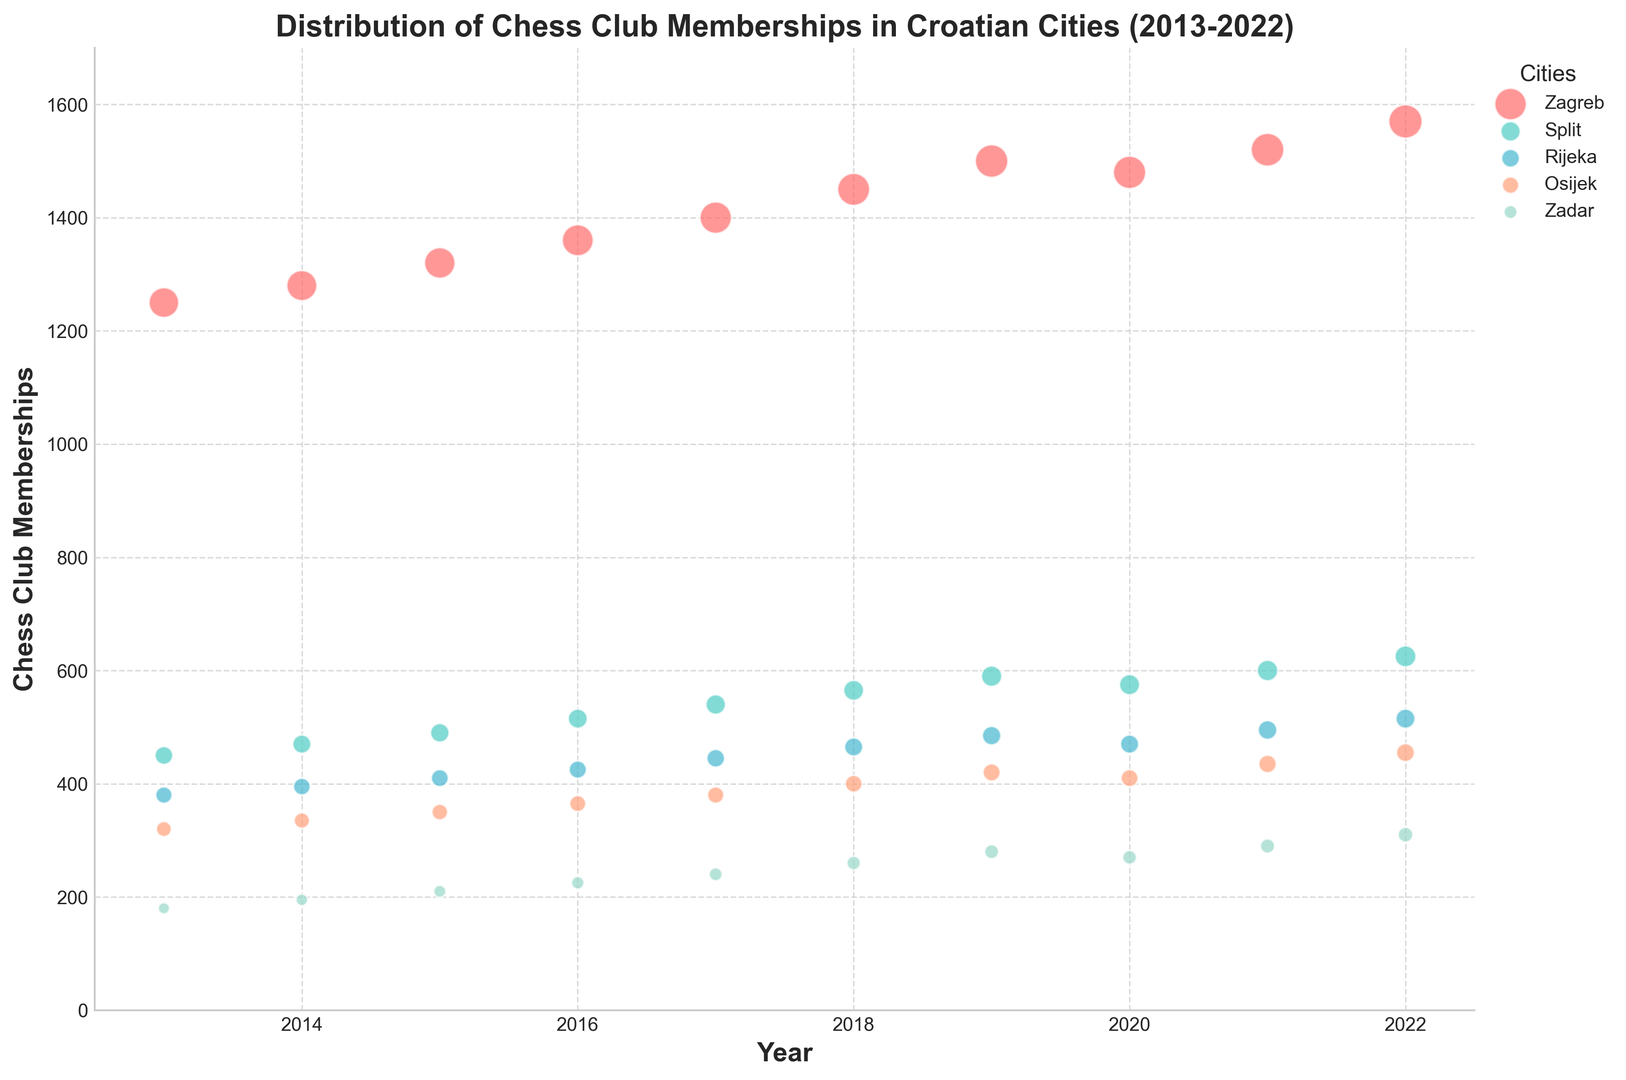What city has the highest chess club membership in 2022? By looking at the plot and identifying the different cities and their respective membership sizes in 2022, we can see that Zagreb has the highest membership.
Answer: Zagreb Which year had the highest growth in memberships for Split compared to the previous year? To determine the highest growth for Split, calculate the difference in memberships year by year and compare. The largest increase appears from 2018 to 2019 (565 to 590).
Answer: 2019 How does the membership trend in Zagreb compare to that in Rijeka over the decade? Analyze the scatter points for Zagreb and Rijeka from 2013 to 2022. Zagreb shows a consistently upward trend with higher values overall, while Rijeka also shows an upward trend but with smaller increases and lower absolute values.
Answer: Zagreb trends higher and increases more consistently than Rijeka What's the sum of chess club memberships in Osijek for the years 2018 and 2019? Look at Osijek's memberships in 2018 (400) and 2019 (420), then sum these two values. 400 + 420 = 820.
Answer: 820 Which city has the smallest membership size in any given year, and in which year does this occur? Identify the lowest scatter point and its corresponding city and year. Zadar has the smallest membership size in 2013, with 180 members.
Answer: Zadar in 2013 Are there any years where the memberships in Zadar remain constant or decrease slightly? By analyzing the plot points over the years for Zadar, we can see that memberships remain constant or decrease slightly between 2019 (280) and 2020 (270).
Answer: Yes, between 2019 and 2020 By how much does the membership in Osijek grow from 2017 to 2021? Find the membership in Osijek for 2017 (380) and 2021 (435). The growth is 435 - 380 = 55.
Answer: 55 Compare the membership trends in Split and Zadar. Which city shows a more rapid increase over the years? By looking at the slopes of the scatter points for Split and Zadar, Split shows a steeper increase compared to the gradual increase in Zadar.
Answer: Split What color represents the city of Rijeka in the plot? By examining the visual attributes and legend, Rijeka is represented by a color like light blue.
Answer: Light blue 